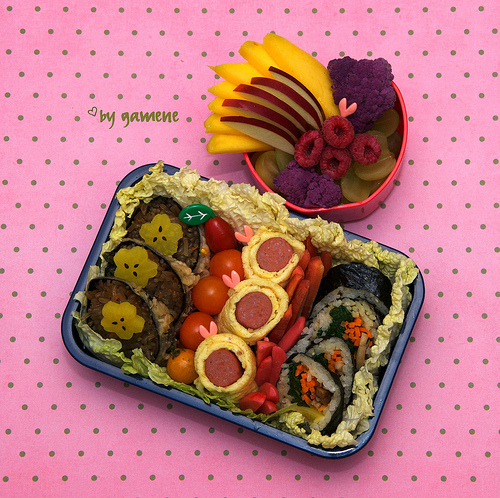<image>
Can you confirm if the apples is next to the bowl? No. The apples is not positioned next to the bowl. They are located in different areas of the scene. 